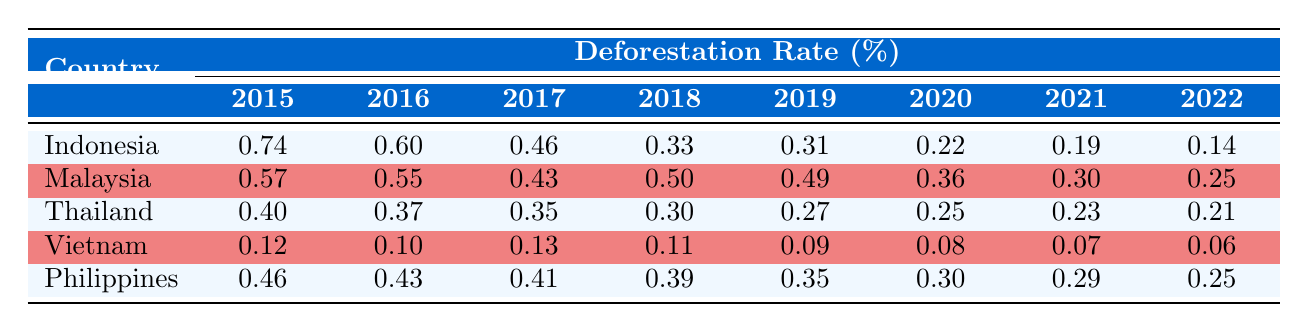What is the deforestation rate of Indonesia in 2020? The table lists the deforestation rate for each country by year. By locating Indonesia in the first row and the column for 2020, the deforestation rate is shown as 0.22 percent.
Answer: 0.22 Which country had the highest deforestation rate in 2015? Looking at the 2015 column, Indonesia has the highest rate at 0.74 percent, compared to Malaysia at 0.57, Thailand at 0.40, Vietnam at 0.12, and Philippines at 0.46.
Answer: Indonesia Calculate the average deforestation rate for Malaysia from 2015 to 2022. To find the average, sum the deforestation rates for Malaysia (0.57 + 0.55 + 0.43 + 0.50 + 0.49 + 0.36 + 0.30 + 0.25 = 3.45) and divide by the number of years (8). The average is 3.45 / 8 = 0.43125, which rounds to 0.43.
Answer: 0.43 Did Thailand's deforestation rate decrease in 2021 compared to 2020? Checking the rates for Thailand in both 2021 (0.23) and 2020 (0.25), it shows a decrease, as 0.23 is less than 0.25.
Answer: Yes What is the overall trend of deforestation rates in Indonesia from 2015 to 2022? Looking at the data points for Indonesia, the rates decreased from 0.74 in 2015 to 0.14 in 2022, indicating a consistent downward trend over these years.
Answer: Decreasing trend Which country experienced the least deforestation rate in 2022? In the 2022 column, Vietnam has the lowest deforestation rate listed at 0.06 percent, compared to other countries' rates: Indonesia at 0.14, Malaysia at 0.25, Thailand at 0.21, and Philippines at 0.25.
Answer: Vietnam Was the deforestation rate in the Philippines lower in 2020 than in 2016? The rate for the Philippines in 2020 is 0.30, and in 2016 it is 0.43. Since 0.30 is less than 0.43, it confirms that the rate was lower in 2020.
Answer: Yes What was the percentage decrease in deforestation rate for Indonesia from 2015 to 2022? The deforestation rate in 2015 is 0.74 and in 2022 is 0.14. First, calculate the difference: 0.74 - 0.14 = 0.60. Then, to find the percentage decrease, divide by the original value: (0.60 / 0.74) * 100 = 81.08 percent decrease.
Answer: 81.08 percent 